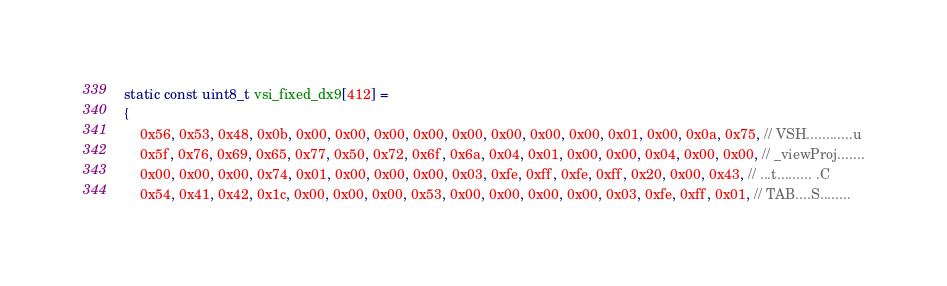<code> <loc_0><loc_0><loc_500><loc_500><_C_>static const uint8_t vsi_fixed_dx9[412] =
{
	0x56, 0x53, 0x48, 0x0b, 0x00, 0x00, 0x00, 0x00, 0x00, 0x00, 0x00, 0x00, 0x01, 0x00, 0x0a, 0x75, // VSH............u
	0x5f, 0x76, 0x69, 0x65, 0x77, 0x50, 0x72, 0x6f, 0x6a, 0x04, 0x01, 0x00, 0x00, 0x04, 0x00, 0x00, // _viewProj.......
	0x00, 0x00, 0x00, 0x74, 0x01, 0x00, 0x00, 0x00, 0x03, 0xfe, 0xff, 0xfe, 0xff, 0x20, 0x00, 0x43, // ...t......... .C
	0x54, 0x41, 0x42, 0x1c, 0x00, 0x00, 0x00, 0x53, 0x00, 0x00, 0x00, 0x00, 0x03, 0xfe, 0xff, 0x01, // TAB....S........</code> 